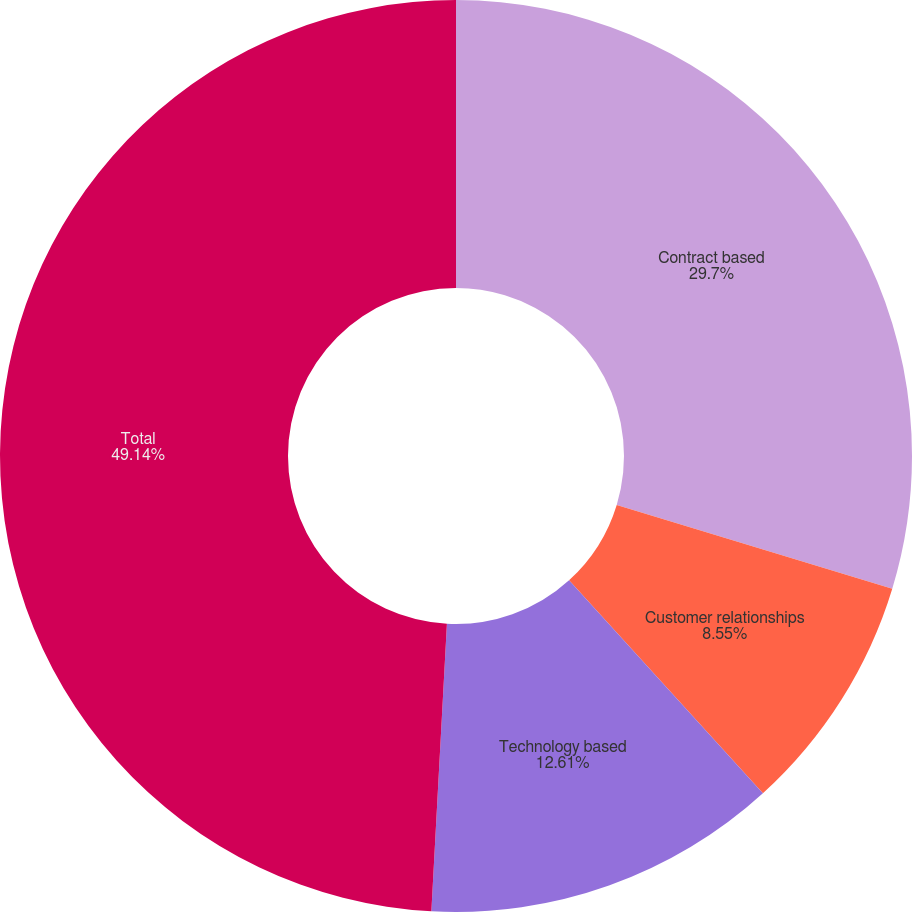<chart> <loc_0><loc_0><loc_500><loc_500><pie_chart><fcel>Contract based<fcel>Customer relationships<fcel>Technology based<fcel>Total<nl><fcel>29.7%<fcel>8.55%<fcel>12.61%<fcel>49.14%<nl></chart> 